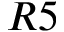<formula> <loc_0><loc_0><loc_500><loc_500>R 5</formula> 